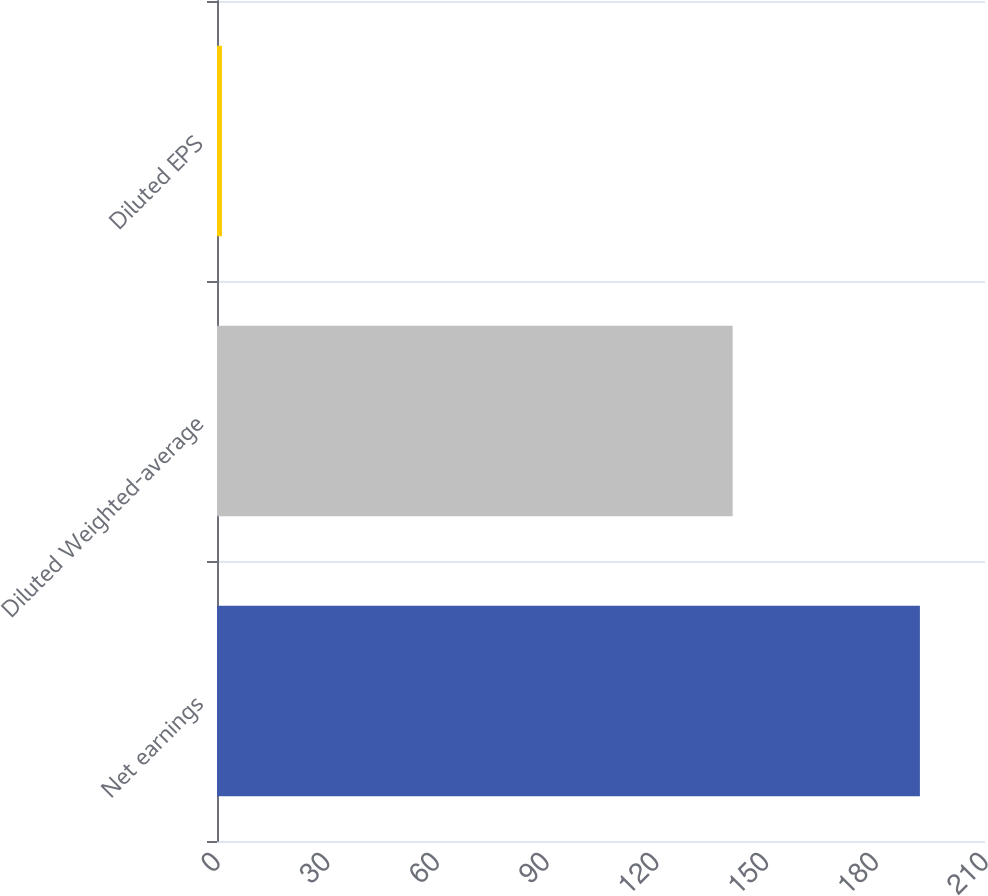Convert chart. <chart><loc_0><loc_0><loc_500><loc_500><bar_chart><fcel>Net earnings<fcel>Diluted Weighted-average<fcel>Diluted EPS<nl><fcel>192.2<fcel>141<fcel>1.36<nl></chart> 